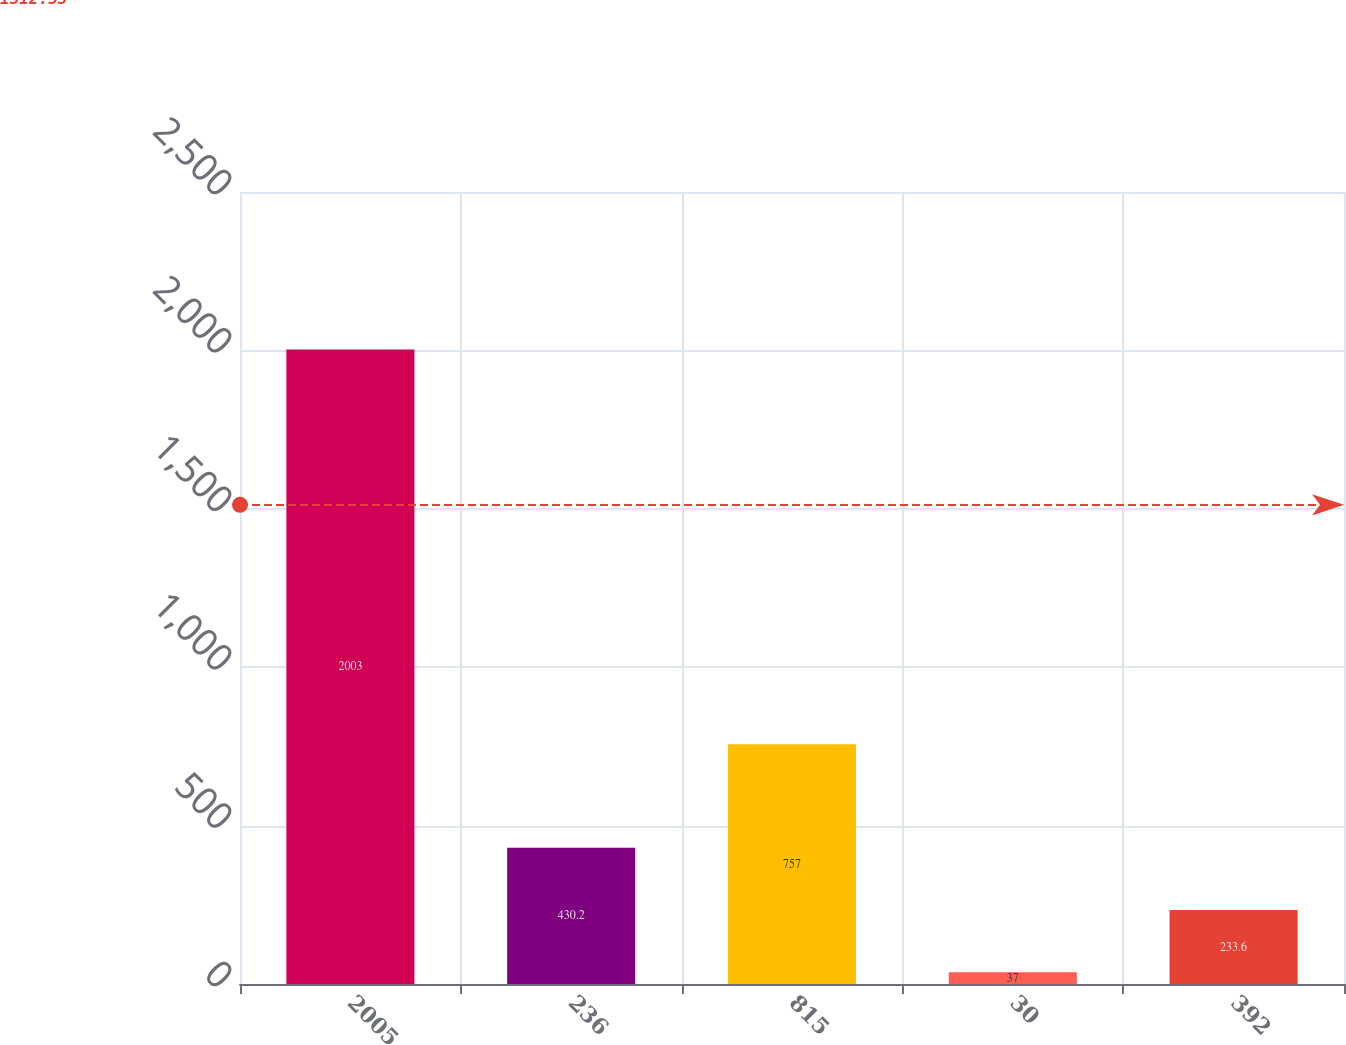<chart> <loc_0><loc_0><loc_500><loc_500><bar_chart><fcel>2005<fcel>236<fcel>815<fcel>30<fcel>392<nl><fcel>2003<fcel>430.2<fcel>757<fcel>37<fcel>233.6<nl></chart> 